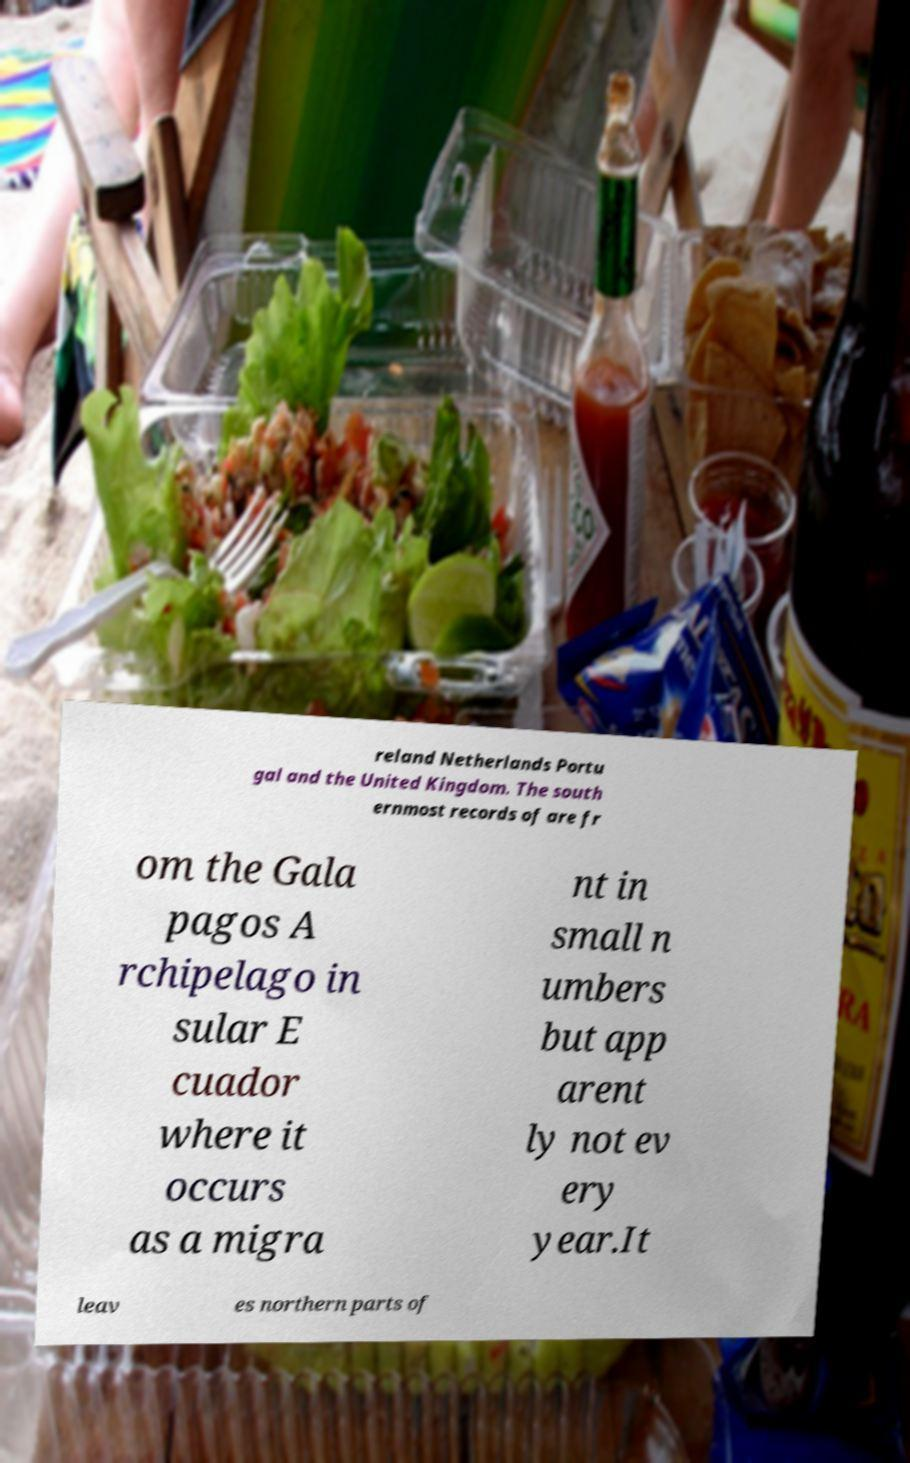Could you extract and type out the text from this image? reland Netherlands Portu gal and the United Kingdom. The south ernmost records of are fr om the Gala pagos A rchipelago in sular E cuador where it occurs as a migra nt in small n umbers but app arent ly not ev ery year.It leav es northern parts of 